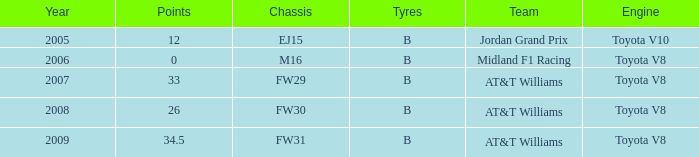What is the earliest year that had under 26 points and a toyota v8 engine? 2006.0. 